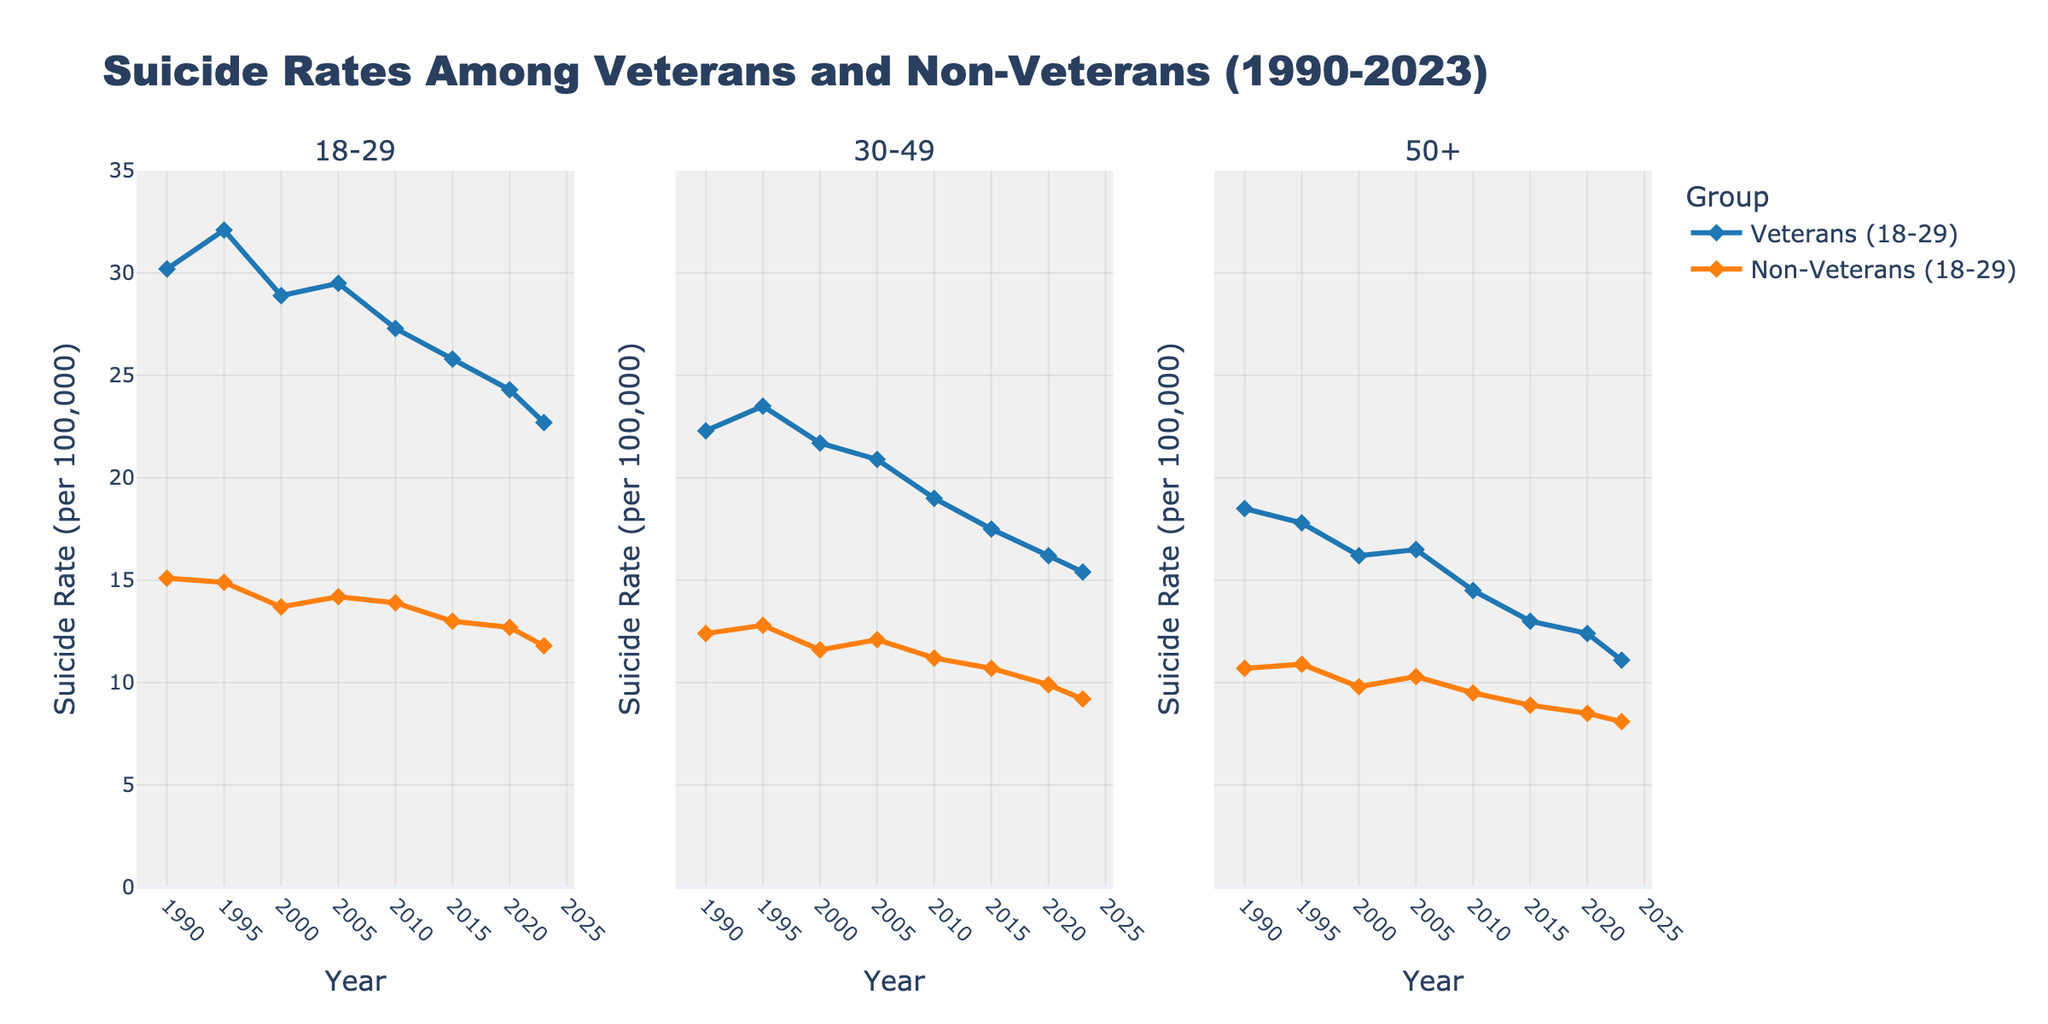What is the title of the plot? The title is displayed at the top of the figure, right above the subplots, in larger and bold text.
Answer: Suicide Rates Among Veterans and Non-Veterans (1990-2023) Which age group has the highest suicide rate in 1990? By looking at the points for the year 1990 across all three subplots and comparing their values, the highest point can be identified. The 18-29 Veterans age group reaches the highest value in that year.
Answer: 18-29 Veterans How do the suicide rates among 18-29 Veterans compare to 18-29 Non-Veterans in 2020? To compare, locate the 2020 points on the leftmost subplot for both Veterans and Non-Veterans and compare their y-values. The Veterans have a higher suicide rate.
Answer: Higher for Veterans What is the overall trend in suicide rates among 50+ Veterans from 1990 to 2023? Focus on the 50+ Veterans line in the rightmost subplot, noting whether it generally increases, decreases, or remains stable over the years. The trend shows a decrease over this period.
Answer: Decreasing Between which years did the 30-49 Veterans experience the most significant drop in suicide rates? Examine the middle subplot for the 30-49 Veterans and identify the steepest decline by comparing the slopes of the lines between consecutive points. The most significant drop occurred between 2000 and 2005.
Answer: 2000-2005 By how much did the suicide rate for 50+ Non-Veterans change from 1990 to 2023? Find the y-values corresponding to 1990 and 2023 for the 50+ Non-Veterans in the rightmost subplot, and compute the difference. It goes from 10.7 in 1990 to 8.1 in 2023, a decrease of 2.6.
Answer: Decreased by 2.6 Which group had the smallest decrease in suicide rates from 1990 to 2023? Compare the differences between 1990 and 2023 across all groups and age brackets. The group with the smallest absolute change is 30-49 Non-Veterans (12.4 to 9.2, a change of 3.2).
Answer: 30-49 Non-Veterans What was the suicide rate for 30-49 Veterans in 2015 and how does it compare to the rate for 30-49 Non-Veterans in the same year? The y-values for 2015 in the middle subplot for both Veterans and Non-Veterans need to be checked. The rate for Veterans is higher at 17.5 compared to Non-Veterans at 10.7.
Answer: Higher for Veterans Was there a consistent decline in suicide rates among 18-29 Veterans from 1990 to 2023? Examine the line for 18-29 Veterans in the leftmost subplot to see if the points show a steady decline without irregular increases. The line does not consistently decline without fluctuation.
Answer: No 